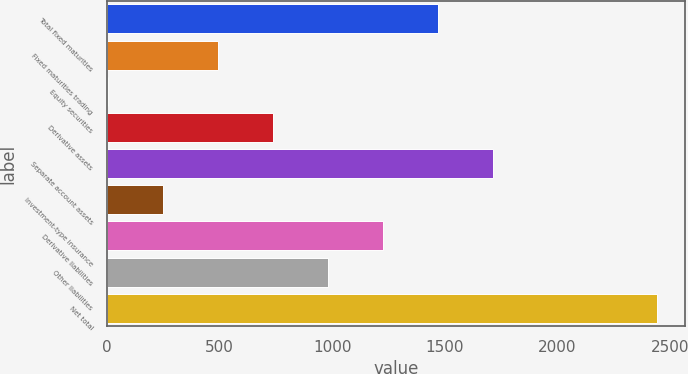Convert chart to OTSL. <chart><loc_0><loc_0><loc_500><loc_500><bar_chart><fcel>Total fixed maturities<fcel>Fixed maturities trading<fcel>Equity securities<fcel>Derivative assets<fcel>Separate account assets<fcel>Investment-type insurance<fcel>Derivative liabilities<fcel>Other liabilities<fcel>Net total<nl><fcel>1467.84<fcel>492.68<fcel>5.1<fcel>736.47<fcel>1711.63<fcel>248.89<fcel>1224.05<fcel>980.26<fcel>2443<nl></chart> 